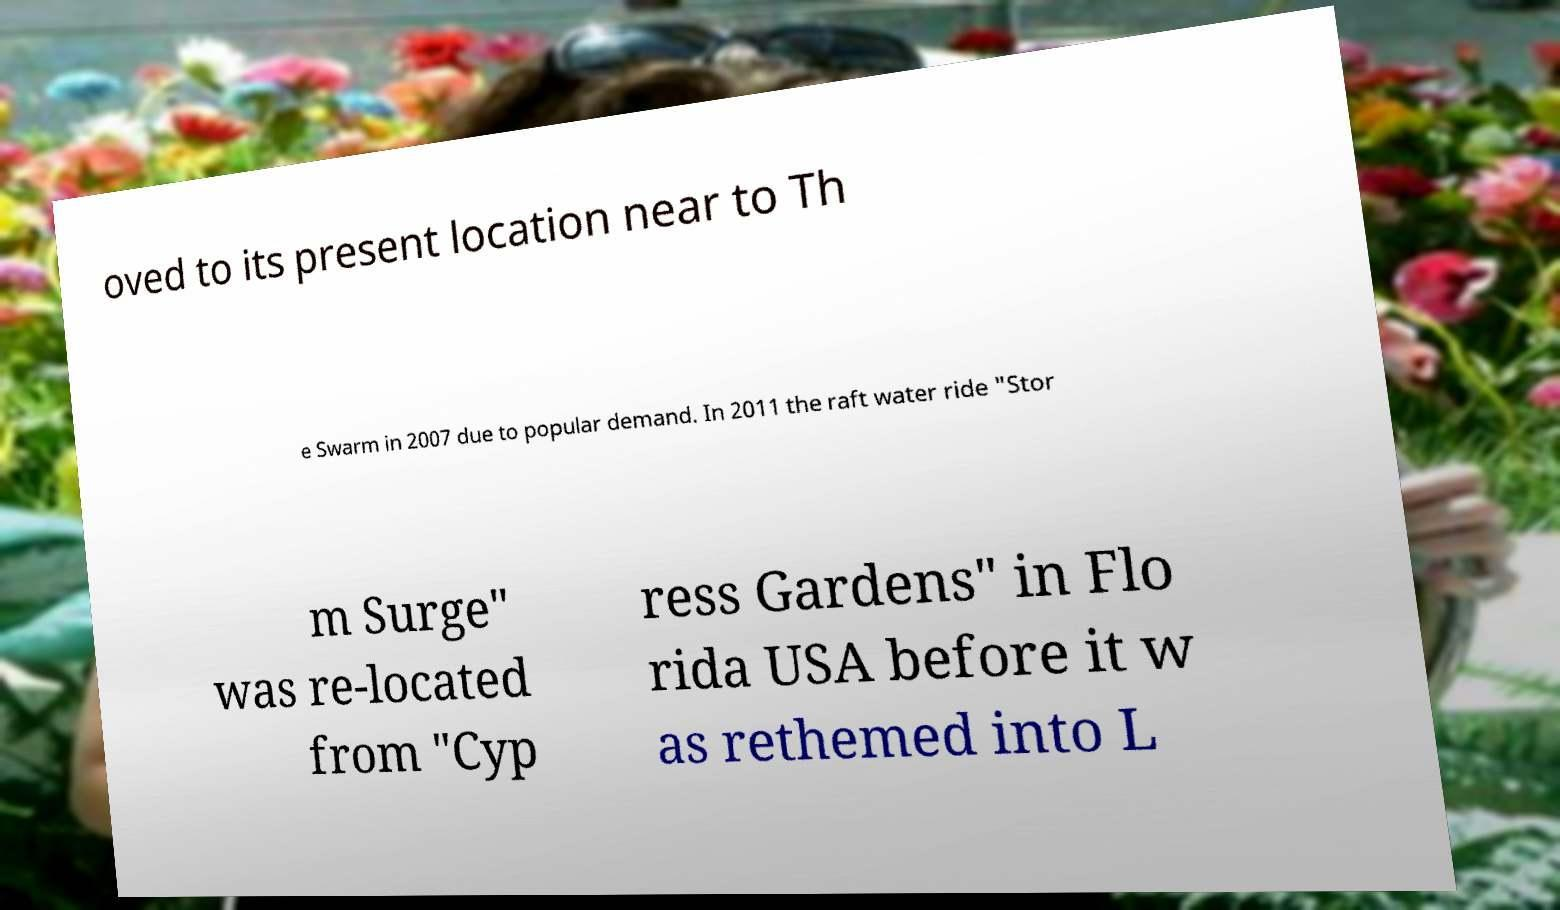Can you read and provide the text displayed in the image?This photo seems to have some interesting text. Can you extract and type it out for me? oved to its present location near to Th e Swarm in 2007 due to popular demand. In 2011 the raft water ride "Stor m Surge" was re-located from "Cyp ress Gardens" in Flo rida USA before it w as rethemed into L 